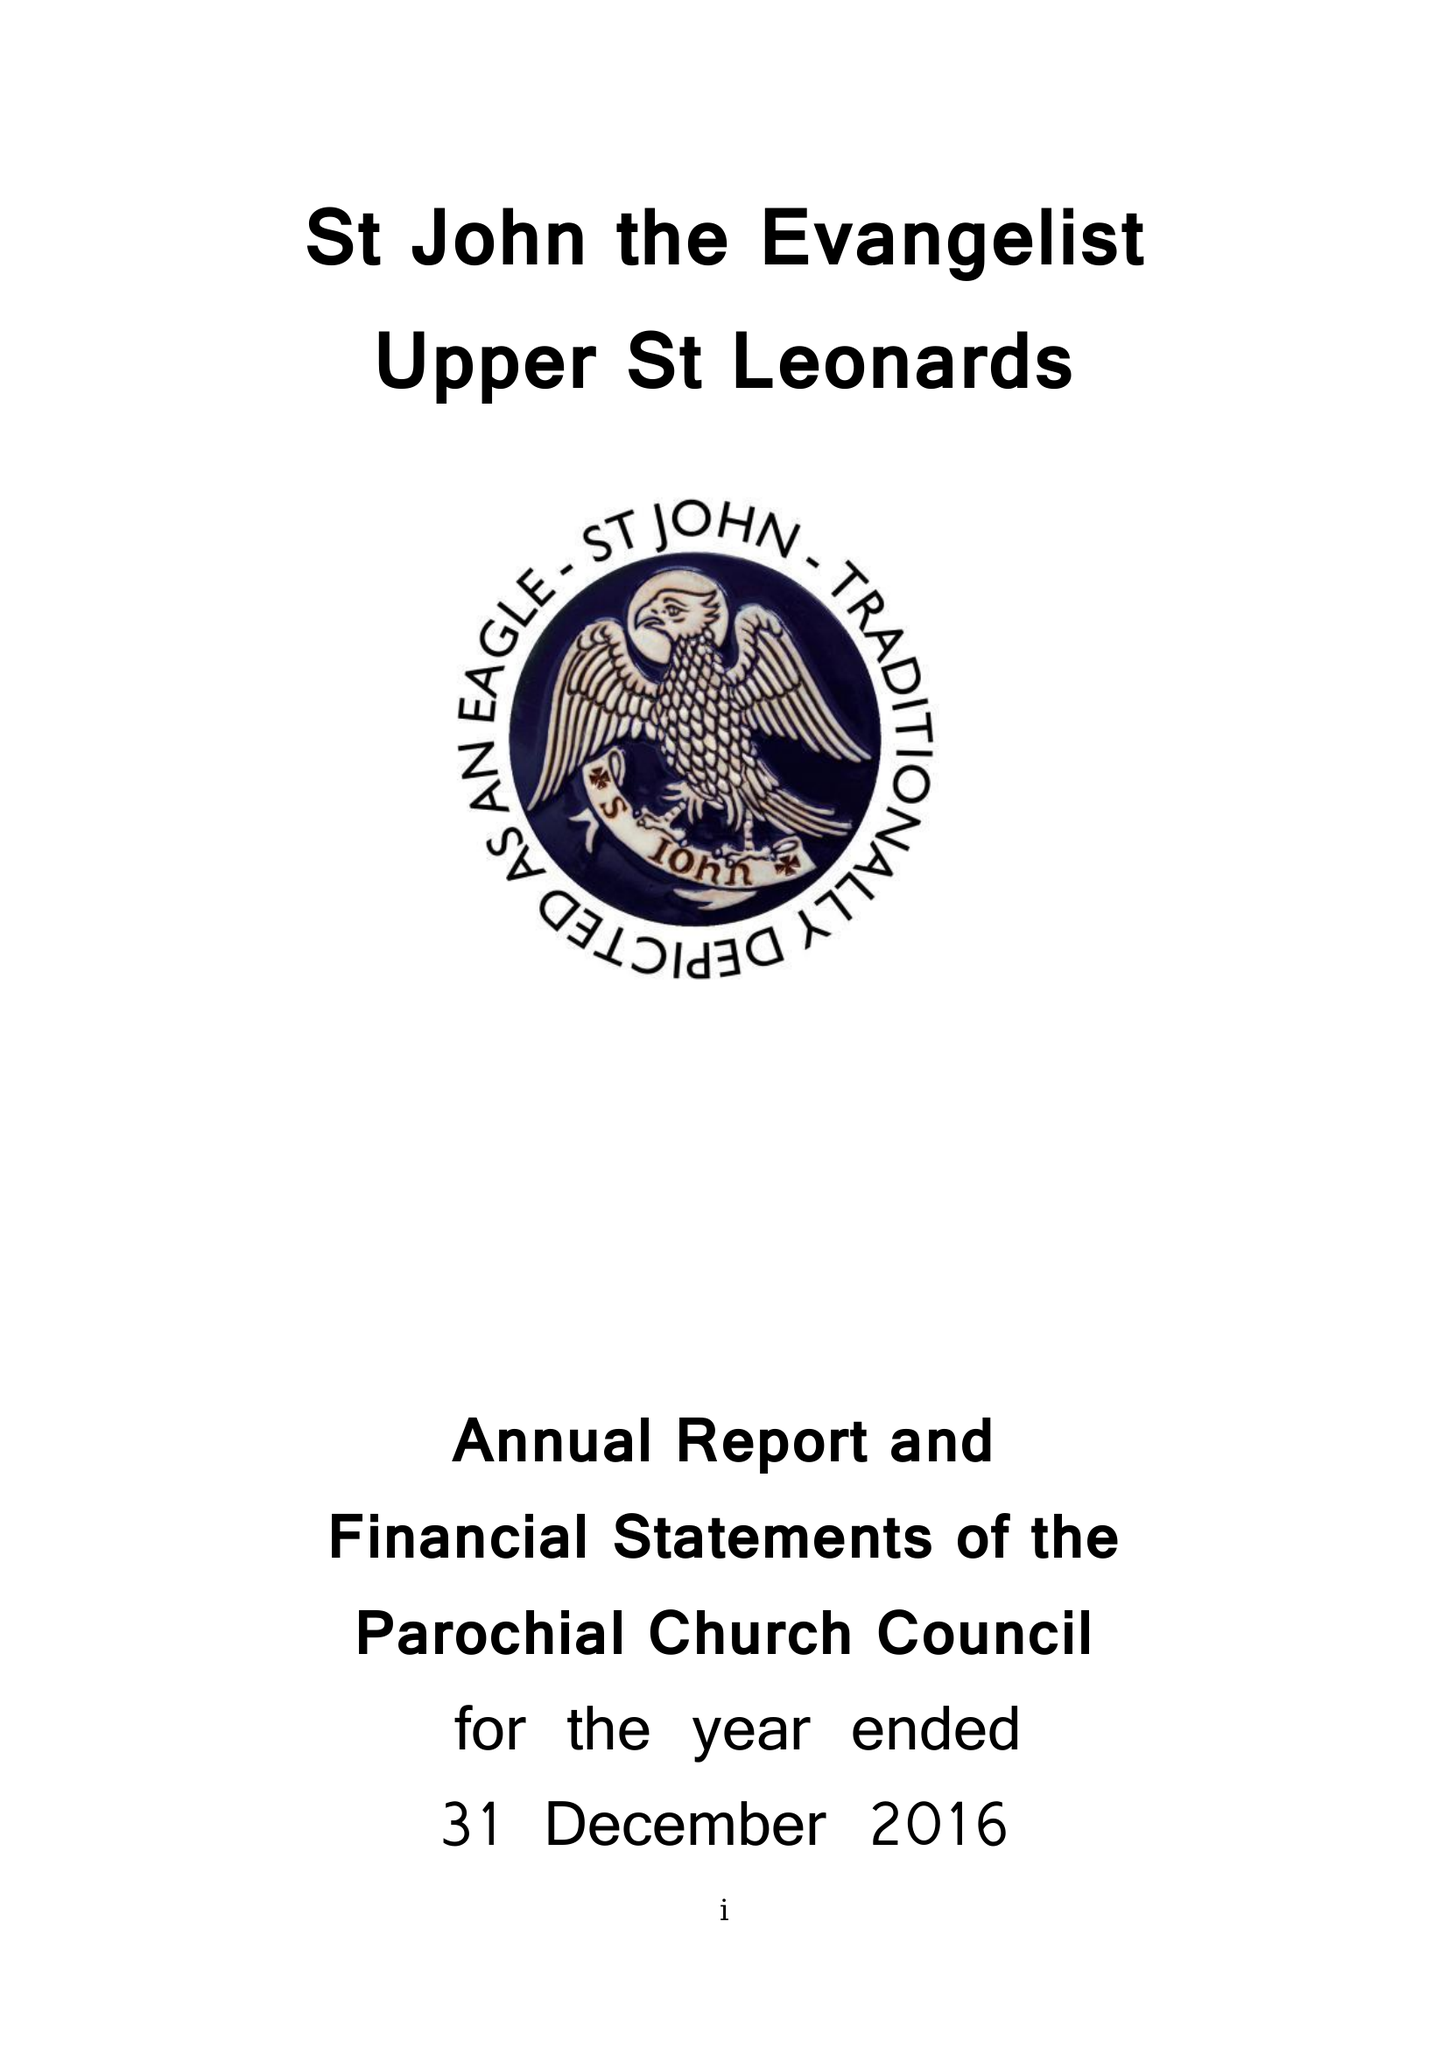What is the value for the address__postcode?
Answer the question using a single word or phrase. TN38 0LF 